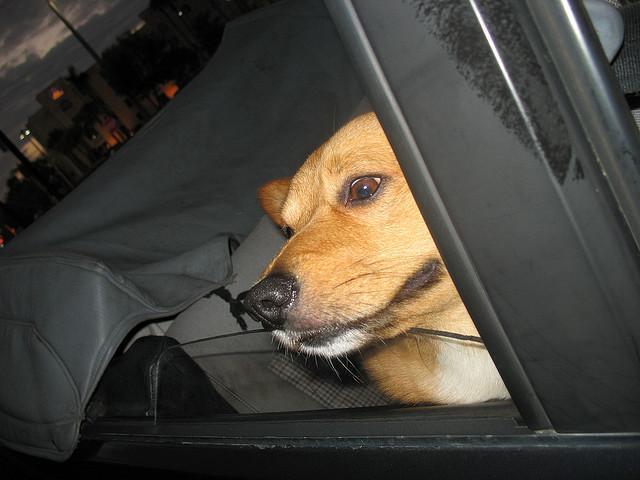How many cars can you see?
Give a very brief answer. 1. 